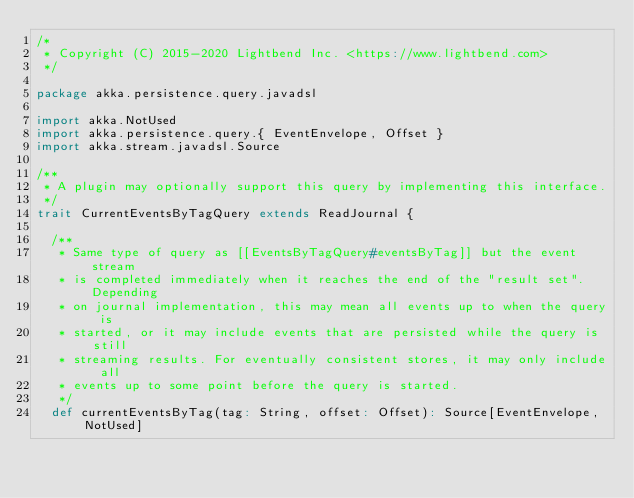<code> <loc_0><loc_0><loc_500><loc_500><_Scala_>/*
 * Copyright (C) 2015-2020 Lightbend Inc. <https://www.lightbend.com>
 */

package akka.persistence.query.javadsl

import akka.NotUsed
import akka.persistence.query.{ EventEnvelope, Offset }
import akka.stream.javadsl.Source

/**
 * A plugin may optionally support this query by implementing this interface.
 */
trait CurrentEventsByTagQuery extends ReadJournal {

  /**
   * Same type of query as [[EventsByTagQuery#eventsByTag]] but the event stream
   * is completed immediately when it reaches the end of the "result set". Depending
   * on journal implementation, this may mean all events up to when the query is
   * started, or it may include events that are persisted while the query is still
   * streaming results. For eventually consistent stores, it may only include all
   * events up to some point before the query is started.
   */
  def currentEventsByTag(tag: String, offset: Offset): Source[EventEnvelope, NotUsed]</code> 